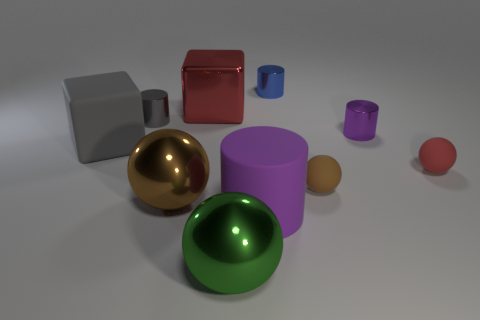What do the sizes and colors of these objects tell us about the context of this scene? The variety in sizes and colors might indicate an educational or demonstrative setup, perhaps used to teach concepts like geometry, light, and shadow, or material properties such as gloss and matte finishes. Are there any indications of real-world scale or is the scene abstract? The scene seems abstract due to the lack of familiar reference points or objects that would suggest a real-world scale. The shapes are generic and could vary in size without additional context. 